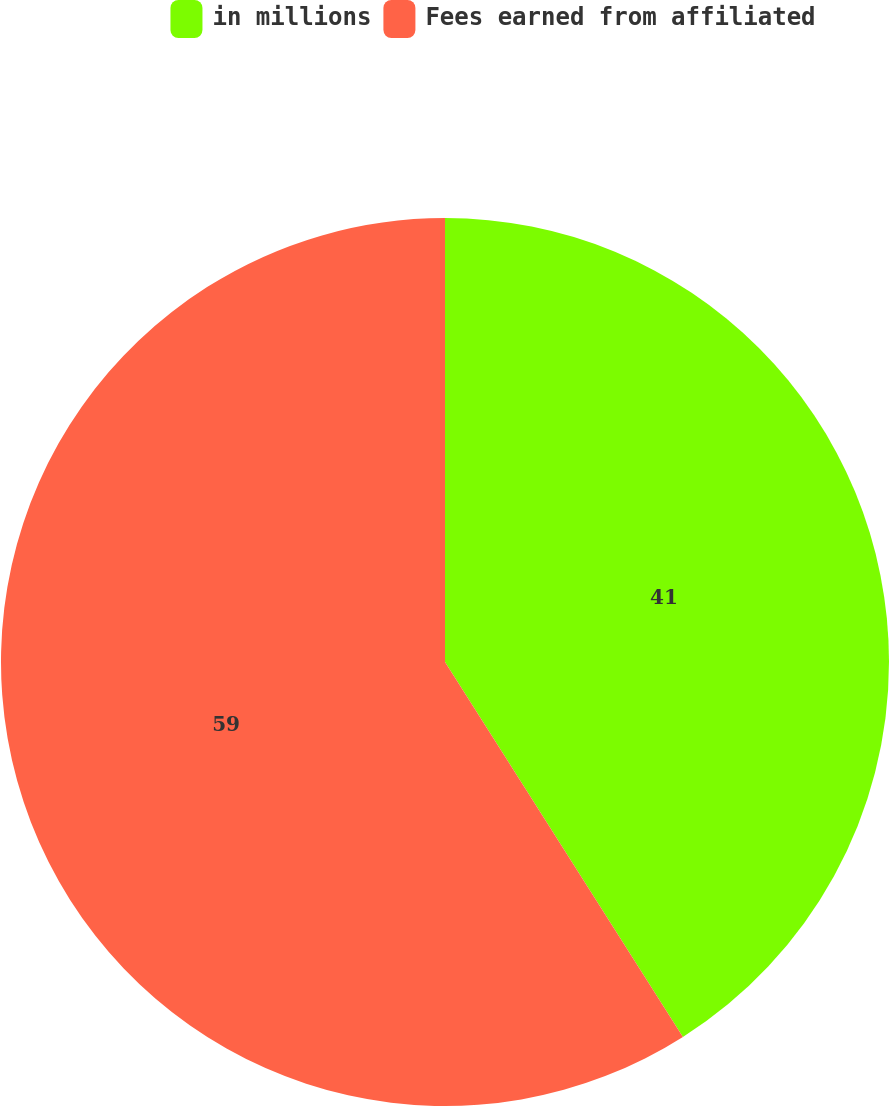<chart> <loc_0><loc_0><loc_500><loc_500><pie_chart><fcel>in millions<fcel>Fees earned from affiliated<nl><fcel>41.0%<fcel>59.0%<nl></chart> 